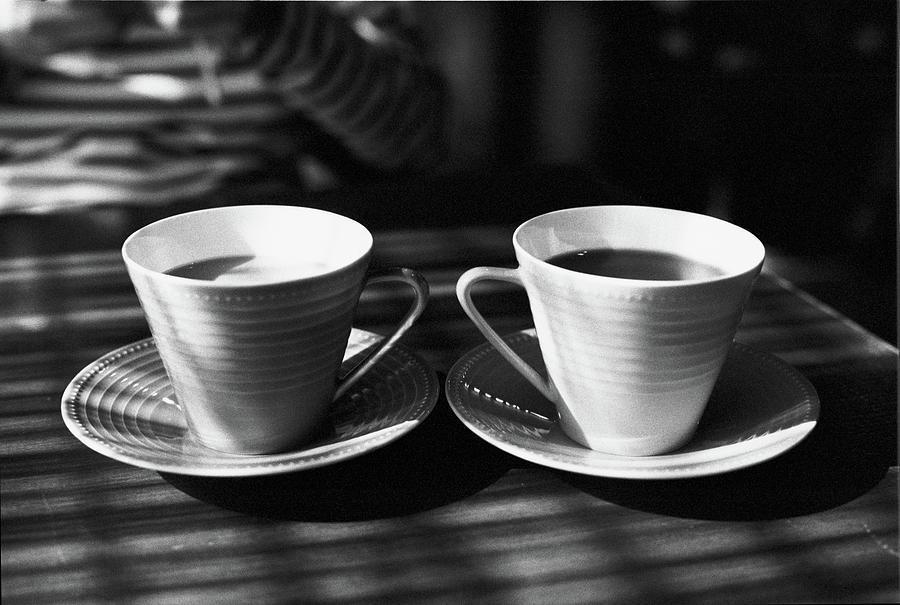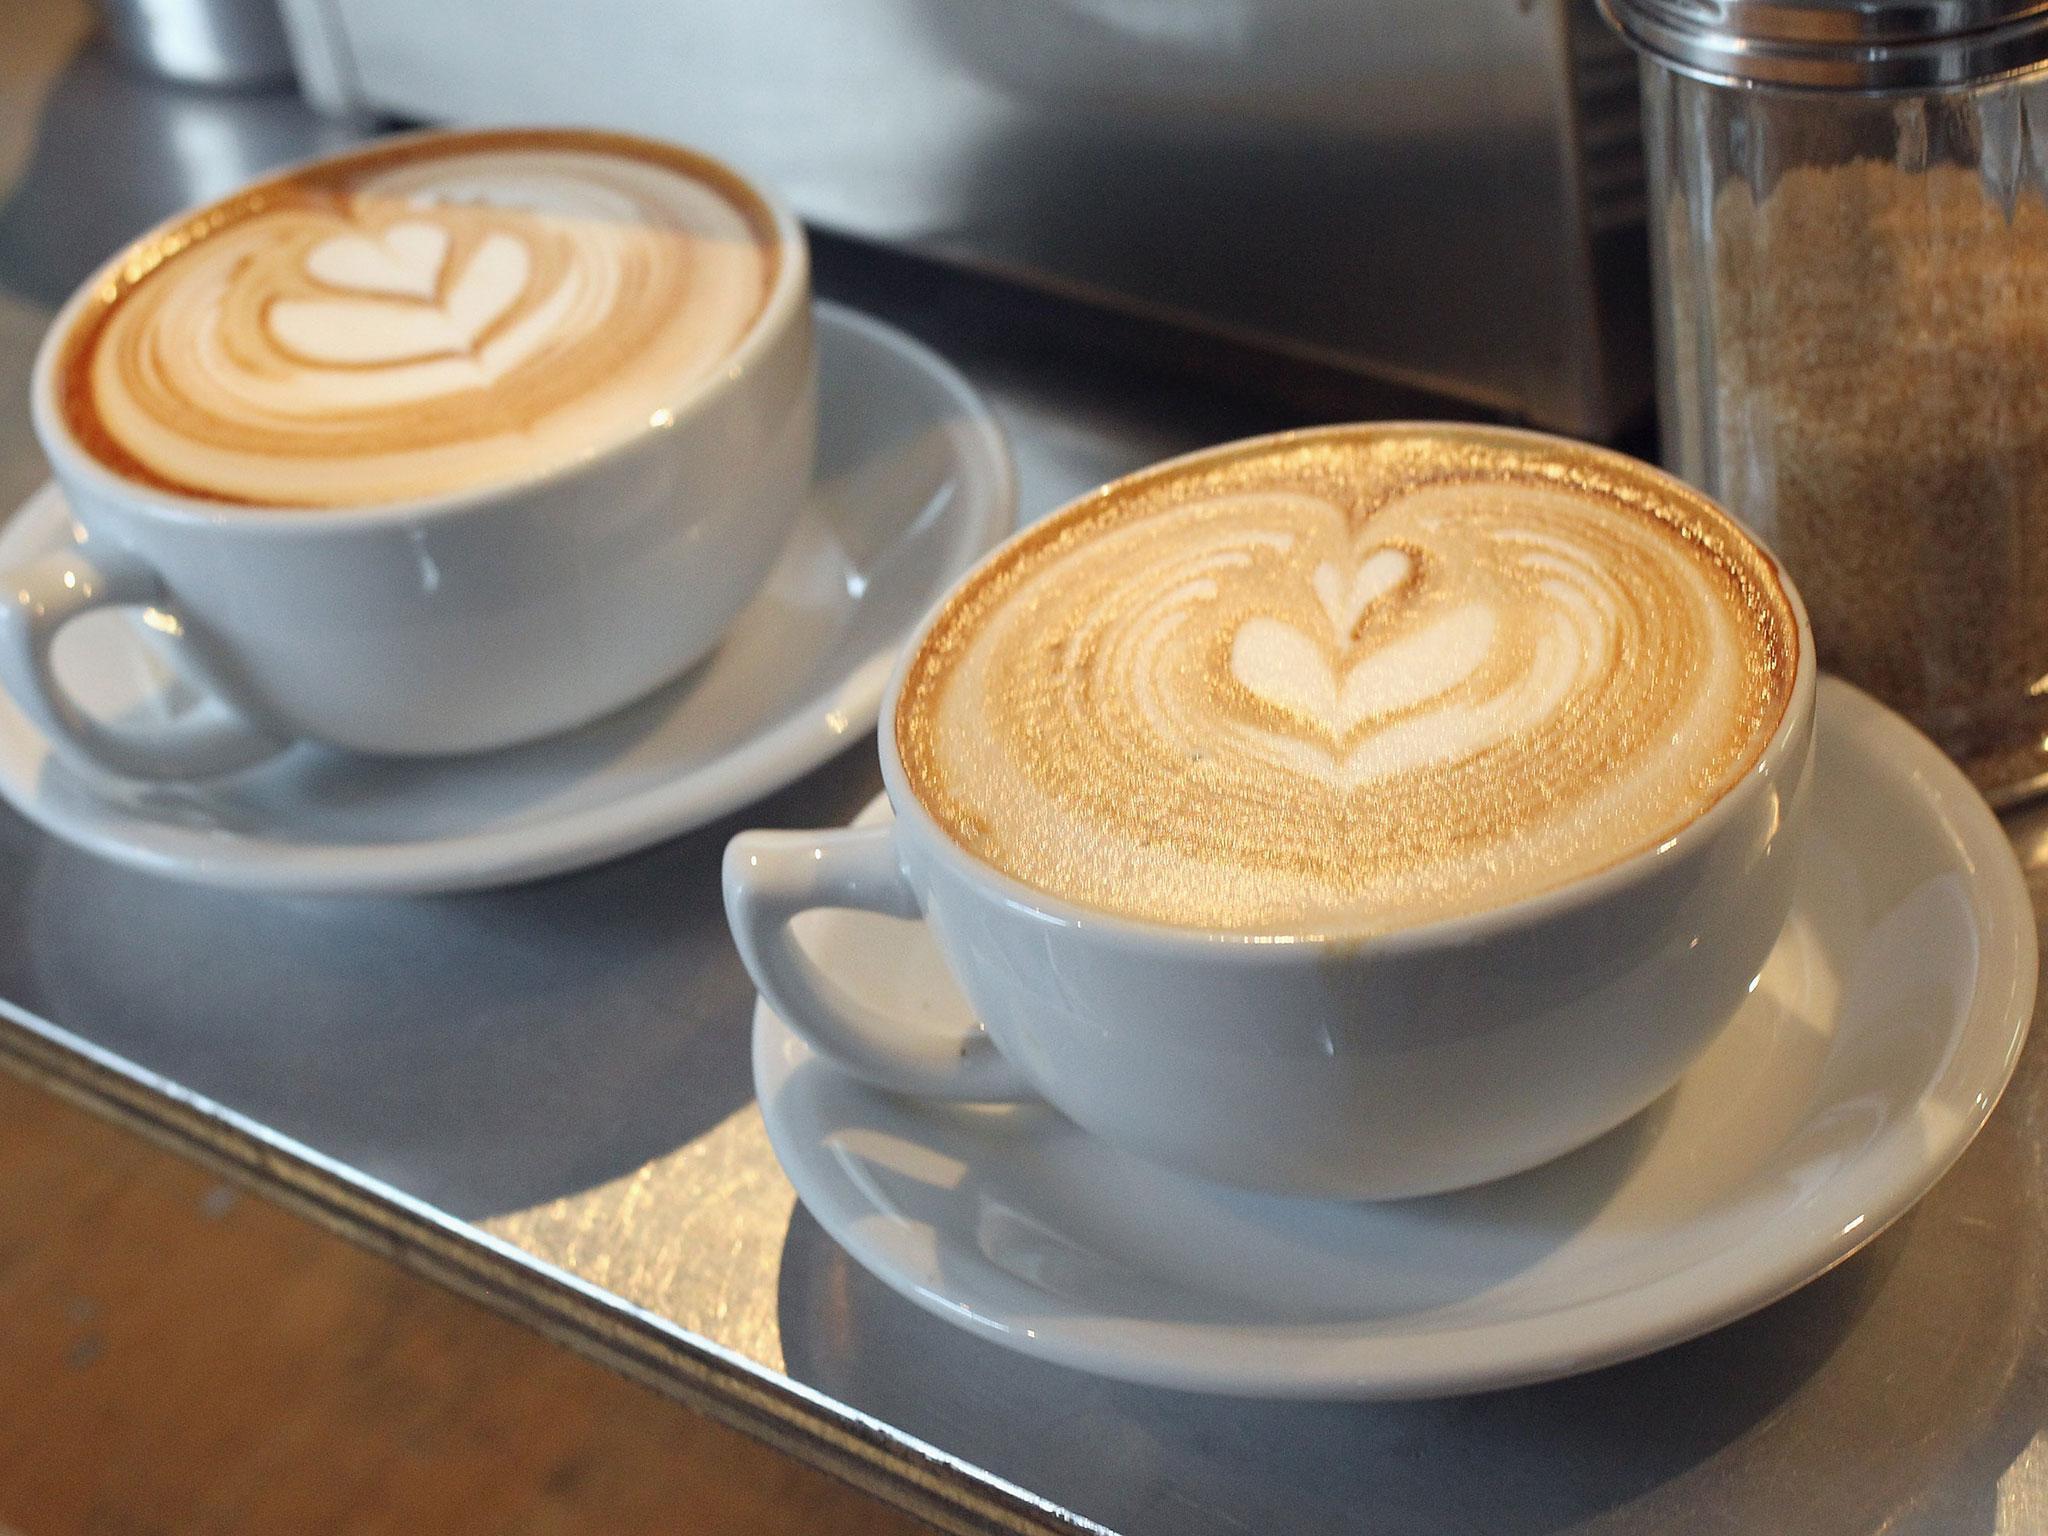The first image is the image on the left, the second image is the image on the right. Considering the images on both sides, is "At least one of the images does not contain any brown wood." valid? Answer yes or no. Yes. 